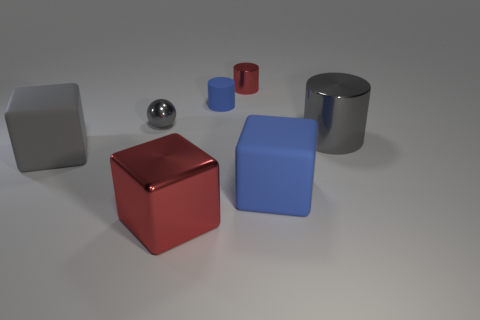Add 3 large metallic objects. How many objects exist? 10 Subtract all cylinders. How many objects are left? 4 Add 2 large blue cubes. How many large blue cubes exist? 3 Subtract 0 brown blocks. How many objects are left? 7 Subtract all matte blocks. Subtract all gray shiny balls. How many objects are left? 4 Add 2 large red shiny objects. How many large red shiny objects are left? 3 